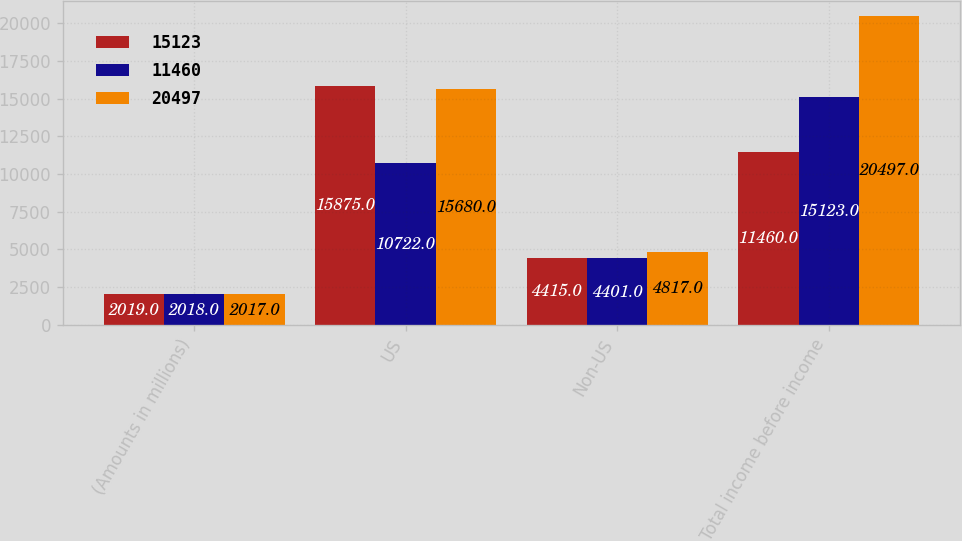Convert chart. <chart><loc_0><loc_0><loc_500><loc_500><stacked_bar_chart><ecel><fcel>(Amounts in millions)<fcel>US<fcel>Non-US<fcel>Total income before income<nl><fcel>15123<fcel>2019<fcel>15875<fcel>4415<fcel>11460<nl><fcel>11460<fcel>2018<fcel>10722<fcel>4401<fcel>15123<nl><fcel>20497<fcel>2017<fcel>15680<fcel>4817<fcel>20497<nl></chart> 